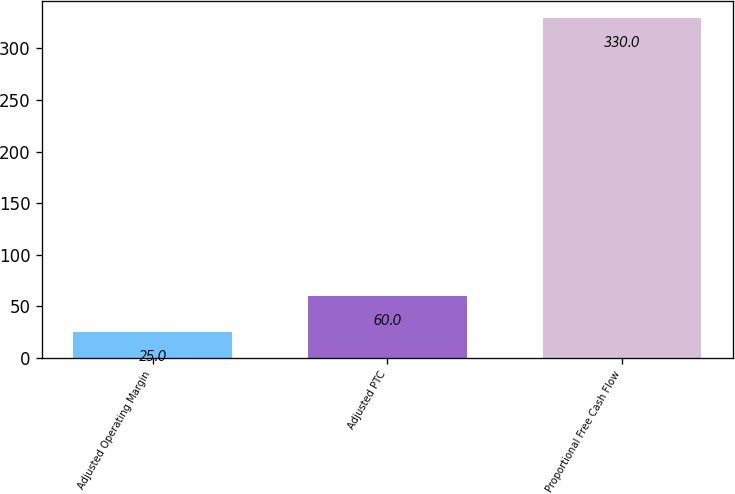Convert chart. <chart><loc_0><loc_0><loc_500><loc_500><bar_chart><fcel>Adjusted Operating Margin<fcel>Adjusted PTC<fcel>Proportional Free Cash Flow<nl><fcel>25<fcel>60<fcel>330<nl></chart> 